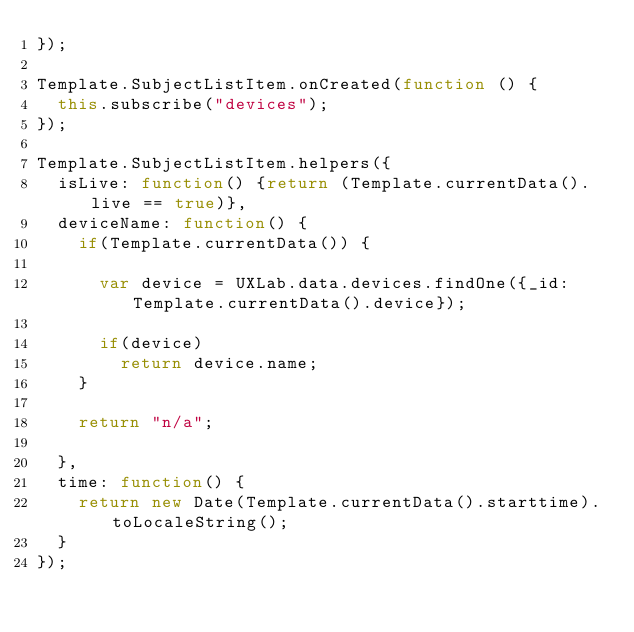<code> <loc_0><loc_0><loc_500><loc_500><_JavaScript_>});

Template.SubjectListItem.onCreated(function () {
  this.subscribe("devices");
});

Template.SubjectListItem.helpers({
  isLive: function() {return (Template.currentData().live == true)},
  deviceName: function() {
    if(Template.currentData()) {

      var device = UXLab.data.devices.findOne({_id: Template.currentData().device});

      if(device)
        return device.name;
    }

    return "n/a";

  },
  time: function() {
    return new Date(Template.currentData().starttime).toLocaleString();
  }
});
</code> 